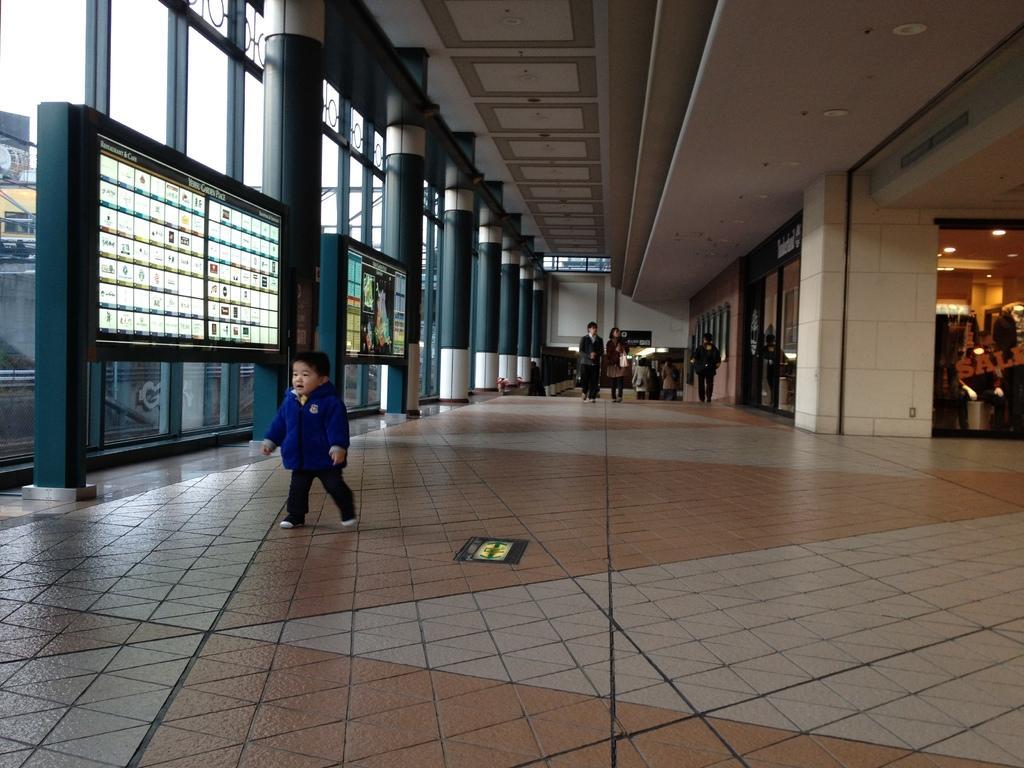Can you describe this image briefly? In this image we can see a kid wearing blue color jacket walking on floor and in the background of the image there are some persons walking, on left side of the image there are some pillars and on right side of image there is some store and top of the image there is roof. 